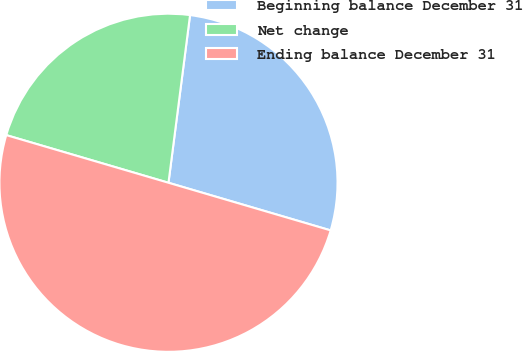Convert chart. <chart><loc_0><loc_0><loc_500><loc_500><pie_chart><fcel>Beginning balance December 31<fcel>Net change<fcel>Ending balance December 31<nl><fcel>27.51%<fcel>22.49%<fcel>50.0%<nl></chart> 